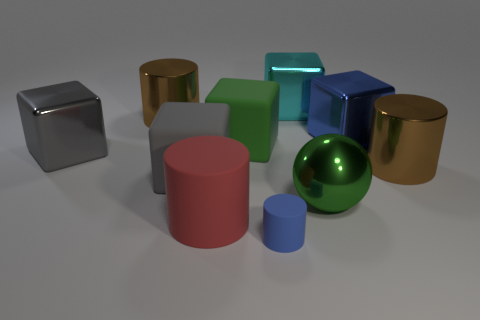Subtract all big blue metal cubes. How many cubes are left? 4 Subtract all cyan cubes. How many cubes are left? 4 Subtract all red cubes. Subtract all purple cylinders. How many cubes are left? 5 Subtract all cylinders. How many objects are left? 6 Add 2 red rubber things. How many red rubber things exist? 3 Subtract 1 cyan cubes. How many objects are left? 9 Subtract all rubber cubes. Subtract all large purple rubber balls. How many objects are left? 8 Add 4 gray rubber objects. How many gray rubber objects are left? 5 